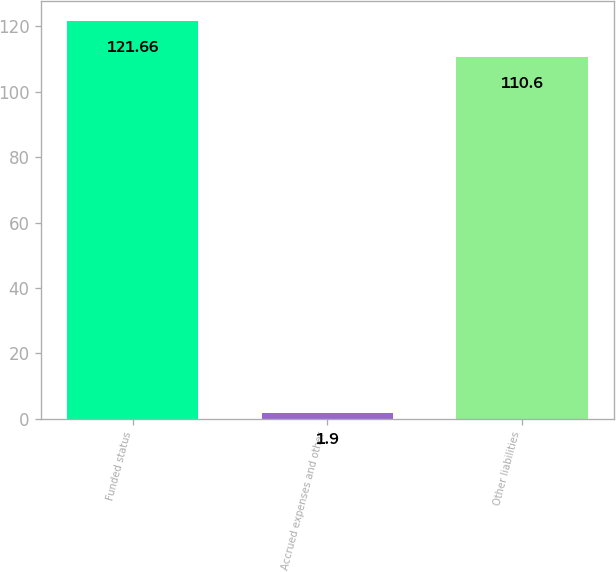Convert chart. <chart><loc_0><loc_0><loc_500><loc_500><bar_chart><fcel>Funded status<fcel>Accrued expenses and other<fcel>Other liabilities<nl><fcel>121.66<fcel>1.9<fcel>110.6<nl></chart> 